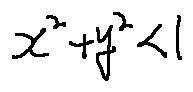<formula> <loc_0><loc_0><loc_500><loc_500>x ^ { 2 } + y ^ { 2 } < 1</formula> 